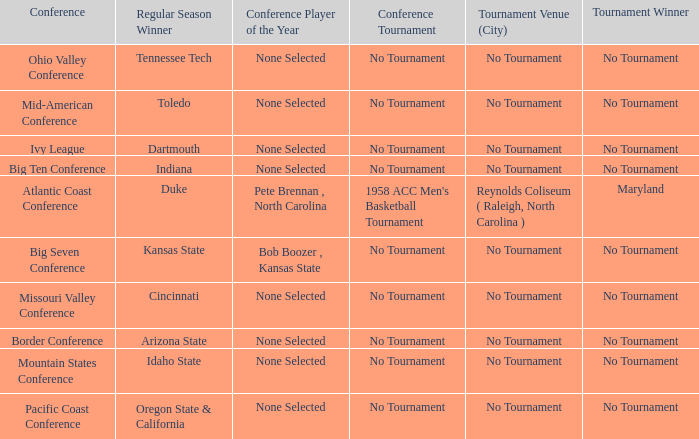Who claimed the championship title in the atlantic coast conference tournament? Maryland. 